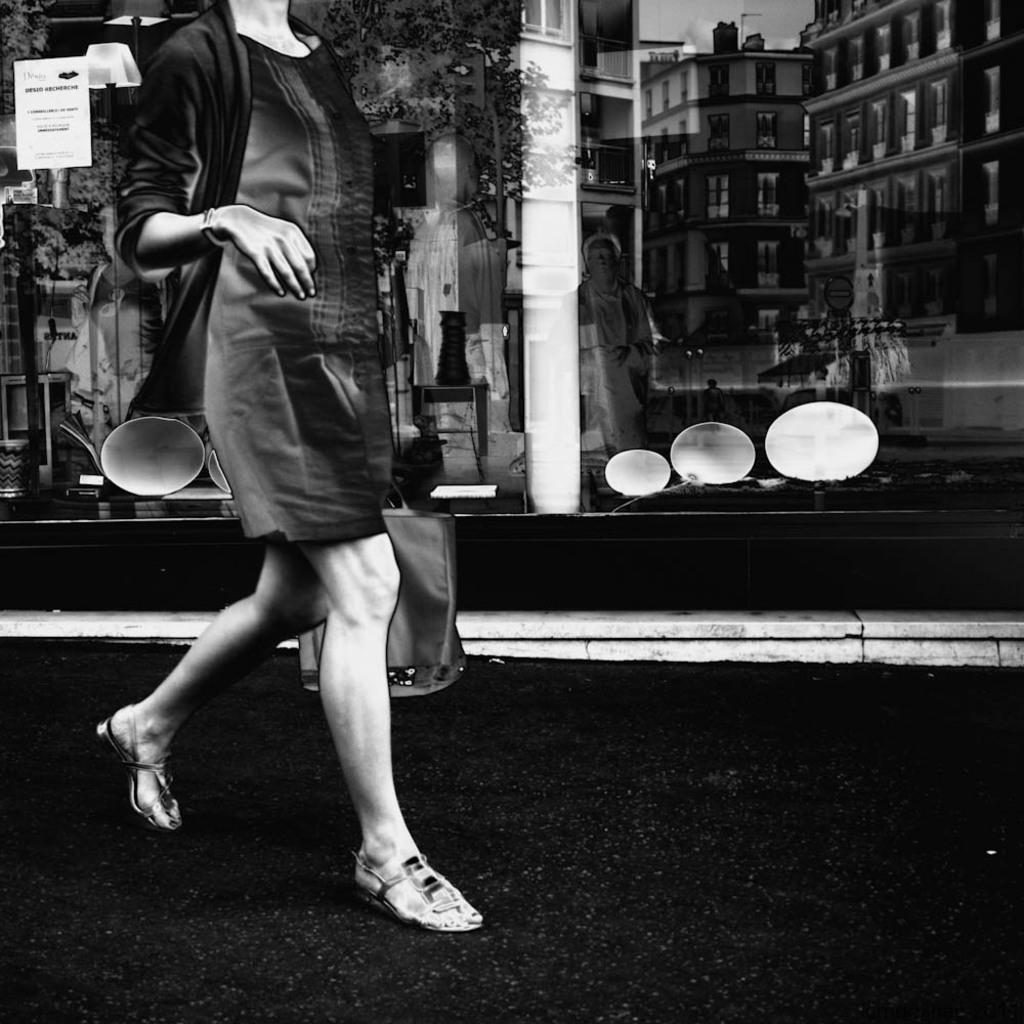What is the main subject of the image? There is a person in the image. What is the person holding in their hand? The person is holding a bag in their hand. What can be seen in the background of the image? There are buildings and trees in the background of the image. What is the color scheme of the image? The image is black and white in color. What type of fireman is shown in the image? There is no fireman present in the image. What unit is the person in the image associated with? The image does not provide any information about the person's unit or affiliation. 